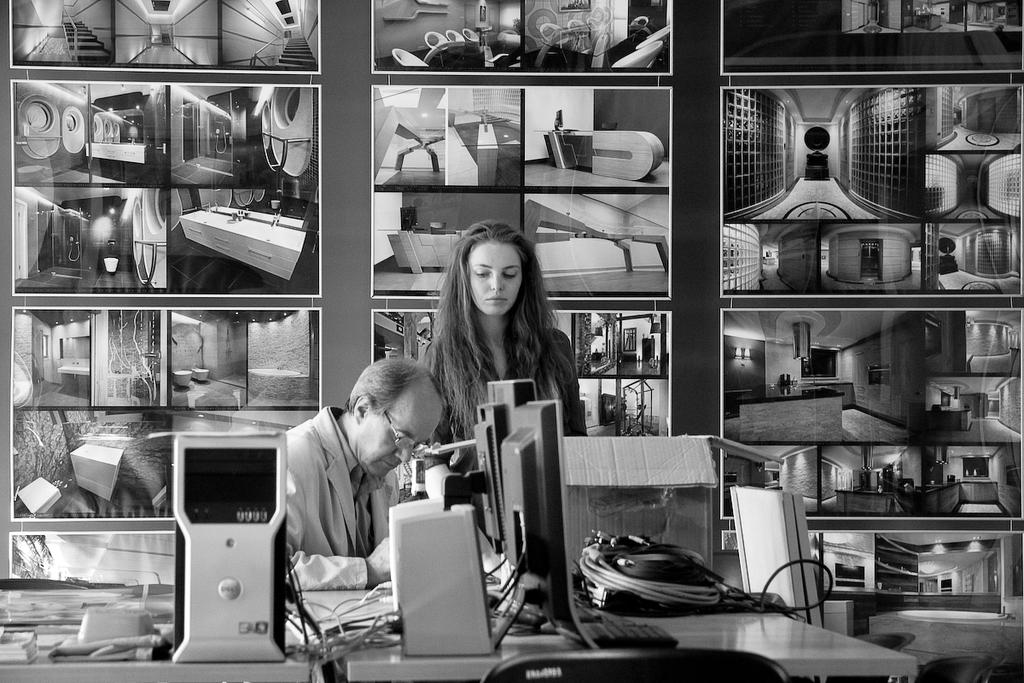What is the color scheme of the image? The image is black and white. What is the man in the image doing? The man is sitting in front of a table. What objects are on the table in the image? The table has computers, bags, and wires on it. What can be seen on the wall in the background of the image? There are photographs on the wall in the background. What theory is the man discussing with the computer in the image? There is no indication in the image that the man is discussing a theory with the computer. 